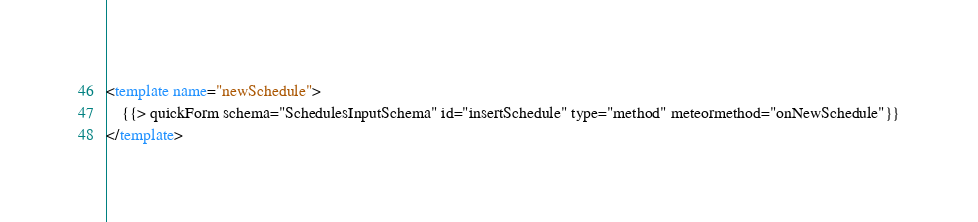<code> <loc_0><loc_0><loc_500><loc_500><_HTML_><template name="newSchedule">
    {{> quickForm schema="SchedulesInputSchema" id="insertSchedule" type="method" meteormethod="onNewSchedule"}}
</template></code> 